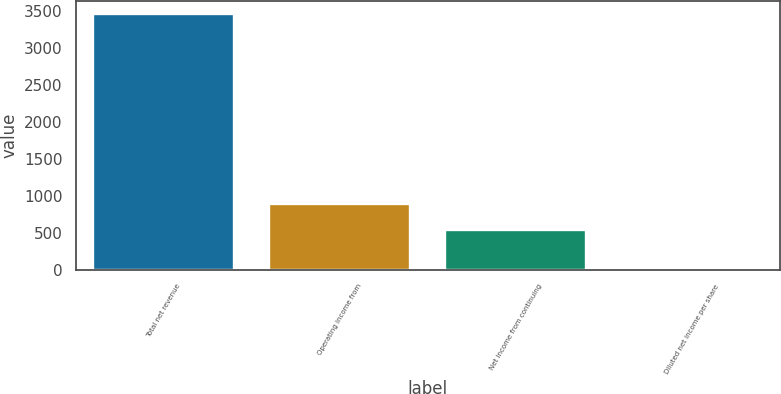Convert chart to OTSL. <chart><loc_0><loc_0><loc_500><loc_500><bar_chart><fcel>Total net revenue<fcel>Operating income from<fcel>Net income from continuing<fcel>Diluted net income per share<nl><fcel>3455<fcel>884.33<fcel>539<fcel>1.66<nl></chart> 